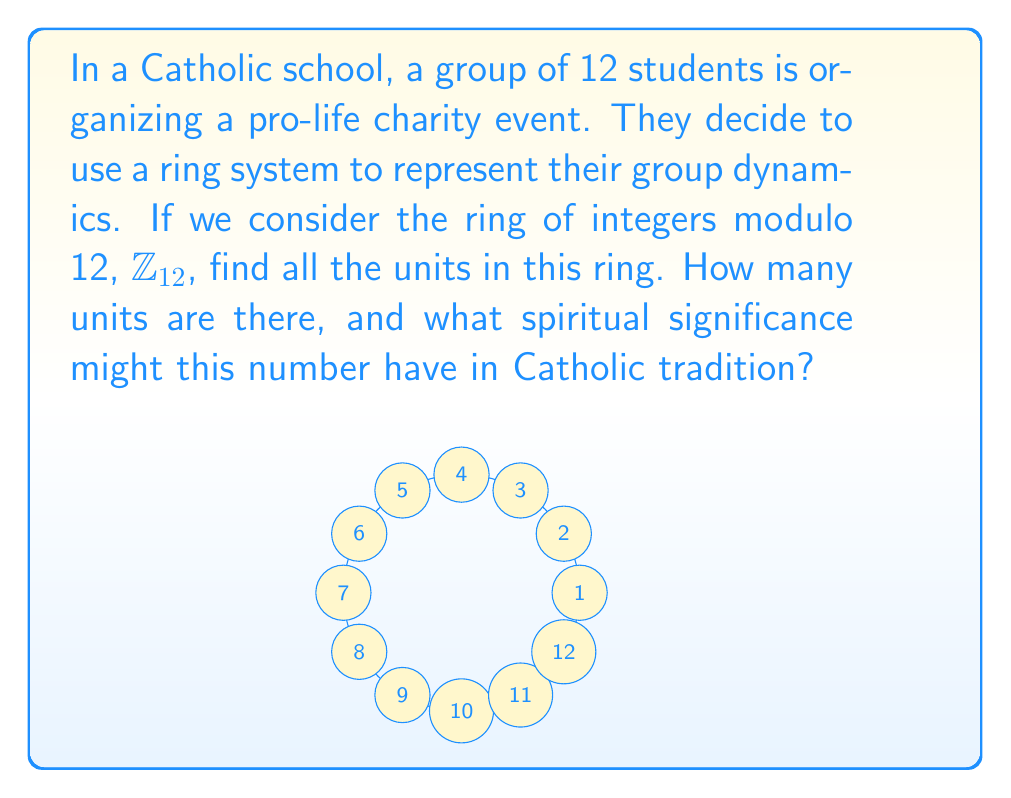Provide a solution to this math problem. Let's approach this step-by-step:

1) In a ring of integers modulo $n$, $\mathbb{Z}_n$, an element $a$ is a unit if and only if it has a multiplicative inverse. This means there exists a $b$ in $\mathbb{Z}_n$ such that $ab \equiv 1 \pmod{n}$.

2) For $\mathbb{Z}_{12}$, we need to find all elements $a$ such that $\gcd(a,12) = 1$.

3) Let's check each element:
   - $\gcd(1,12) = 1$, so 1 is a unit
   - $\gcd(2,12) = 2$, not a unit
   - $\gcd(3,12) = 3$, not a unit
   - $\gcd(4,12) = 4$, not a unit
   - $\gcd(5,12) = 1$, so 5 is a unit
   - $\gcd(6,12) = 6$, not a unit
   - $\gcd(7,12) = 1$, so 7 is a unit
   - $\gcd(8,12) = 4$, not a unit
   - $\gcd(9,12) = 3$, not a unit
   - $\gcd(10,12) = 2$, not a unit
   - $\gcd(11,12) = 1$, so 11 is a unit

4) Therefore, the units in $\mathbb{Z}_{12}$ are 1, 5, 7, and 11.

5) There are 4 units in total.

6) In Catholic tradition, the number 4 has significance as it represents the four Evangelists (Matthew, Mark, Luke, and John) who spread the Gospel of life and salvation.
Answer: Units in $\mathbb{Z}_{12}$: $\{1, 5, 7, 11\}$ 